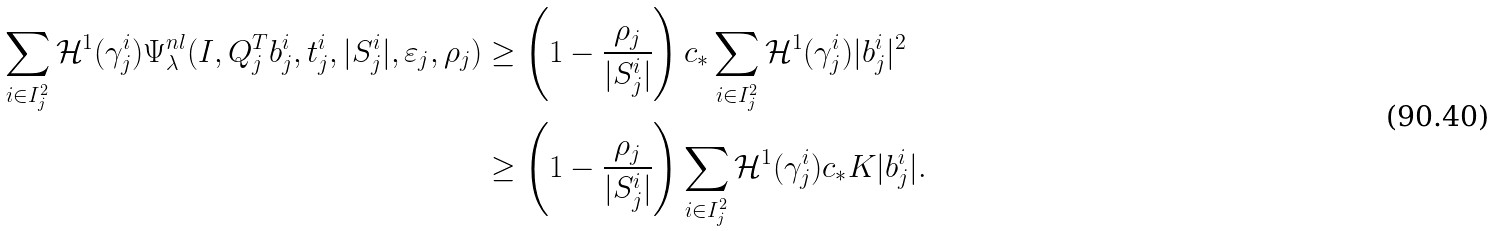Convert formula to latex. <formula><loc_0><loc_0><loc_500><loc_500>\sum _ { i \in I _ { j } ^ { 2 } } \mathcal { H } ^ { 1 } ( \gamma _ { j } ^ { i } ) \Psi _ { \lambda } ^ { n l } ( I , Q _ { j } ^ { T } b _ { j } ^ { i } , t _ { j } ^ { i } , | S _ { j } ^ { i } | , \varepsilon _ { j } , \rho _ { j } ) & \geq \left ( 1 - \frac { \rho _ { j } } { | S ^ { i } _ { j } | } \right ) c _ { * } \sum _ { i \in I _ { j } ^ { 2 } } \mathcal { H } ^ { 1 } ( \gamma _ { j } ^ { i } ) | b _ { j } ^ { i } | ^ { 2 } \\ & \geq \left ( 1 - \frac { \rho _ { j } } { | S ^ { i } _ { j } | } \right ) \sum _ { i \in I _ { j } ^ { 2 } } \mathcal { H } ^ { 1 } ( \gamma _ { j } ^ { i } ) c _ { * } K | b _ { j } ^ { i } | .</formula> 